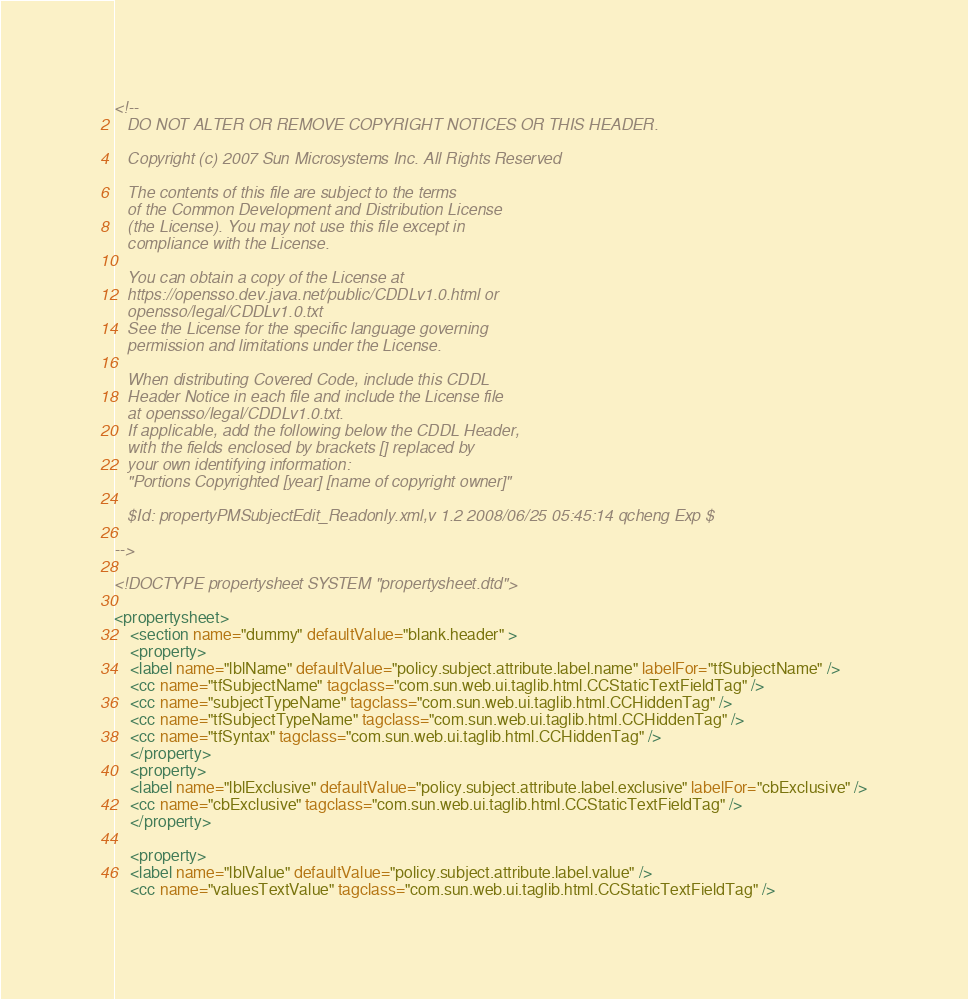<code> <loc_0><loc_0><loc_500><loc_500><_XML_><!--
   DO NOT ALTER OR REMOVE COPYRIGHT NOTICES OR THIS HEADER.
  
   Copyright (c) 2007 Sun Microsystems Inc. All Rights Reserved
  
   The contents of this file are subject to the terms
   of the Common Development and Distribution License
   (the License). You may not use this file except in
   compliance with the License.

   You can obtain a copy of the License at
   https://opensso.dev.java.net/public/CDDLv1.0.html or
   opensso/legal/CDDLv1.0.txt
   See the License for the specific language governing
   permission and limitations under the License.

   When distributing Covered Code, include this CDDL
   Header Notice in each file and include the License file
   at opensso/legal/CDDLv1.0.txt.
   If applicable, add the following below the CDDL Header,
   with the fields enclosed by brackets [] replaced by
   your own identifying information:
   "Portions Copyrighted [year] [name of copyright owner]"

   $Id: propertyPMSubjectEdit_Readonly.xml,v 1.2 2008/06/25 05:45:14 qcheng Exp $

-->

<!DOCTYPE propertysheet SYSTEM "propertysheet.dtd">

<propertysheet>
    <section name="dummy" defaultValue="blank.header" >
    <property>
	<label name="lblName" defaultValue="policy.subject.attribute.label.name" labelFor="tfSubjectName" />
	<cc name="tfSubjectName" tagclass="com.sun.web.ui.taglib.html.CCStaticTextFieldTag" />
	<cc name="subjectTypeName" tagclass="com.sun.web.ui.taglib.html.CCHiddenTag" />
	<cc name="tfSubjectTypeName" tagclass="com.sun.web.ui.taglib.html.CCHiddenTag" />
	<cc name="tfSyntax" tagclass="com.sun.web.ui.taglib.html.CCHiddenTag" />
    </property>
    <property>
	<label name="lblExclusive" defaultValue="policy.subject.attribute.label.exclusive" labelFor="cbExclusive" />
	<cc name="cbExclusive" tagclass="com.sun.web.ui.taglib.html.CCStaticTextFieldTag" />
    </property>

    <property>
	<label name="lblValue" defaultValue="policy.subject.attribute.label.value" />
	<cc name="valuesTextValue" tagclass="com.sun.web.ui.taglib.html.CCStaticTextFieldTag" /></code> 